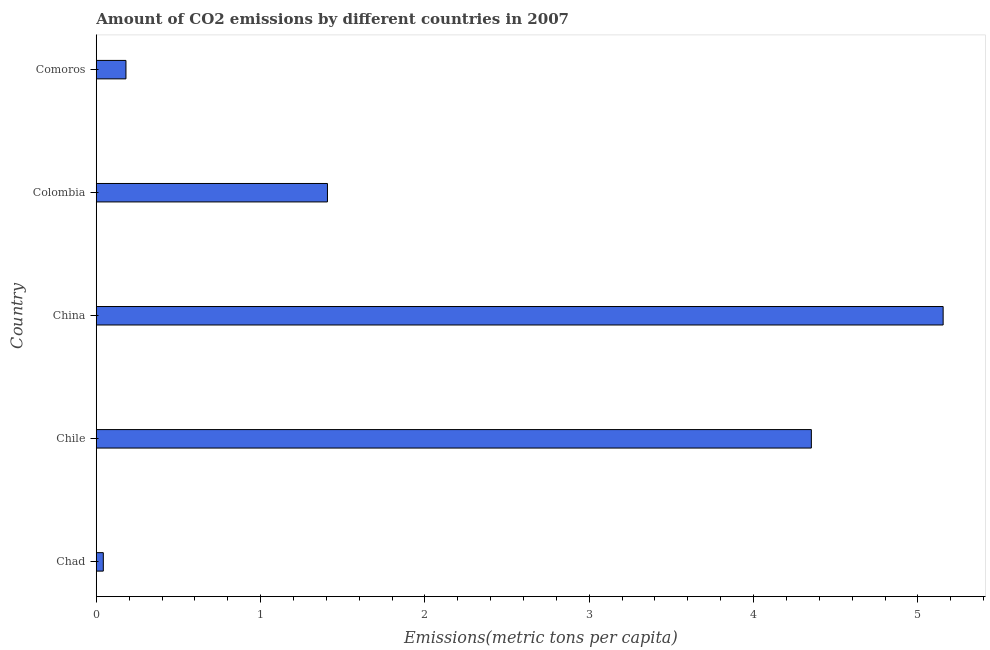Does the graph contain any zero values?
Ensure brevity in your answer.  No. Does the graph contain grids?
Make the answer very short. No. What is the title of the graph?
Give a very brief answer. Amount of CO2 emissions by different countries in 2007. What is the label or title of the X-axis?
Offer a terse response. Emissions(metric tons per capita). What is the amount of co2 emissions in Comoros?
Ensure brevity in your answer.  0.18. Across all countries, what is the maximum amount of co2 emissions?
Provide a succinct answer. 5.15. Across all countries, what is the minimum amount of co2 emissions?
Your response must be concise. 0.04. In which country was the amount of co2 emissions maximum?
Offer a terse response. China. In which country was the amount of co2 emissions minimum?
Make the answer very short. Chad. What is the sum of the amount of co2 emissions?
Your response must be concise. 11.14. What is the difference between the amount of co2 emissions in China and Colombia?
Your response must be concise. 3.75. What is the average amount of co2 emissions per country?
Your answer should be compact. 2.23. What is the median amount of co2 emissions?
Your response must be concise. 1.41. In how many countries, is the amount of co2 emissions greater than 3 metric tons per capita?
Your answer should be very brief. 2. What is the ratio of the amount of co2 emissions in Chad to that in Chile?
Your answer should be compact. 0.01. Is the amount of co2 emissions in Chad less than that in Colombia?
Offer a very short reply. Yes. What is the difference between the highest and the second highest amount of co2 emissions?
Offer a terse response. 0.8. Is the sum of the amount of co2 emissions in Chad and Chile greater than the maximum amount of co2 emissions across all countries?
Provide a short and direct response. No. What is the difference between the highest and the lowest amount of co2 emissions?
Your answer should be very brief. 5.11. How many bars are there?
Keep it short and to the point. 5. What is the difference between two consecutive major ticks on the X-axis?
Ensure brevity in your answer.  1. Are the values on the major ticks of X-axis written in scientific E-notation?
Ensure brevity in your answer.  No. What is the Emissions(metric tons per capita) of Chad?
Make the answer very short. 0.04. What is the Emissions(metric tons per capita) in Chile?
Your answer should be compact. 4.35. What is the Emissions(metric tons per capita) in China?
Your response must be concise. 5.15. What is the Emissions(metric tons per capita) in Colombia?
Keep it short and to the point. 1.41. What is the Emissions(metric tons per capita) in Comoros?
Your response must be concise. 0.18. What is the difference between the Emissions(metric tons per capita) in Chad and Chile?
Give a very brief answer. -4.31. What is the difference between the Emissions(metric tons per capita) in Chad and China?
Make the answer very short. -5.11. What is the difference between the Emissions(metric tons per capita) in Chad and Colombia?
Offer a terse response. -1.36. What is the difference between the Emissions(metric tons per capita) in Chad and Comoros?
Your response must be concise. -0.14. What is the difference between the Emissions(metric tons per capita) in Chile and China?
Your answer should be very brief. -0.8. What is the difference between the Emissions(metric tons per capita) in Chile and Colombia?
Provide a short and direct response. 2.94. What is the difference between the Emissions(metric tons per capita) in Chile and Comoros?
Provide a short and direct response. 4.17. What is the difference between the Emissions(metric tons per capita) in China and Colombia?
Offer a terse response. 3.75. What is the difference between the Emissions(metric tons per capita) in China and Comoros?
Provide a succinct answer. 4.97. What is the difference between the Emissions(metric tons per capita) in Colombia and Comoros?
Provide a short and direct response. 1.23. What is the ratio of the Emissions(metric tons per capita) in Chad to that in China?
Your response must be concise. 0.01. What is the ratio of the Emissions(metric tons per capita) in Chad to that in Comoros?
Give a very brief answer. 0.24. What is the ratio of the Emissions(metric tons per capita) in Chile to that in China?
Keep it short and to the point. 0.84. What is the ratio of the Emissions(metric tons per capita) in Chile to that in Colombia?
Your answer should be compact. 3.09. What is the ratio of the Emissions(metric tons per capita) in Chile to that in Comoros?
Your answer should be compact. 24.08. What is the ratio of the Emissions(metric tons per capita) in China to that in Colombia?
Ensure brevity in your answer.  3.66. What is the ratio of the Emissions(metric tons per capita) in China to that in Comoros?
Offer a very short reply. 28.52. What is the ratio of the Emissions(metric tons per capita) in Colombia to that in Comoros?
Make the answer very short. 7.79. 